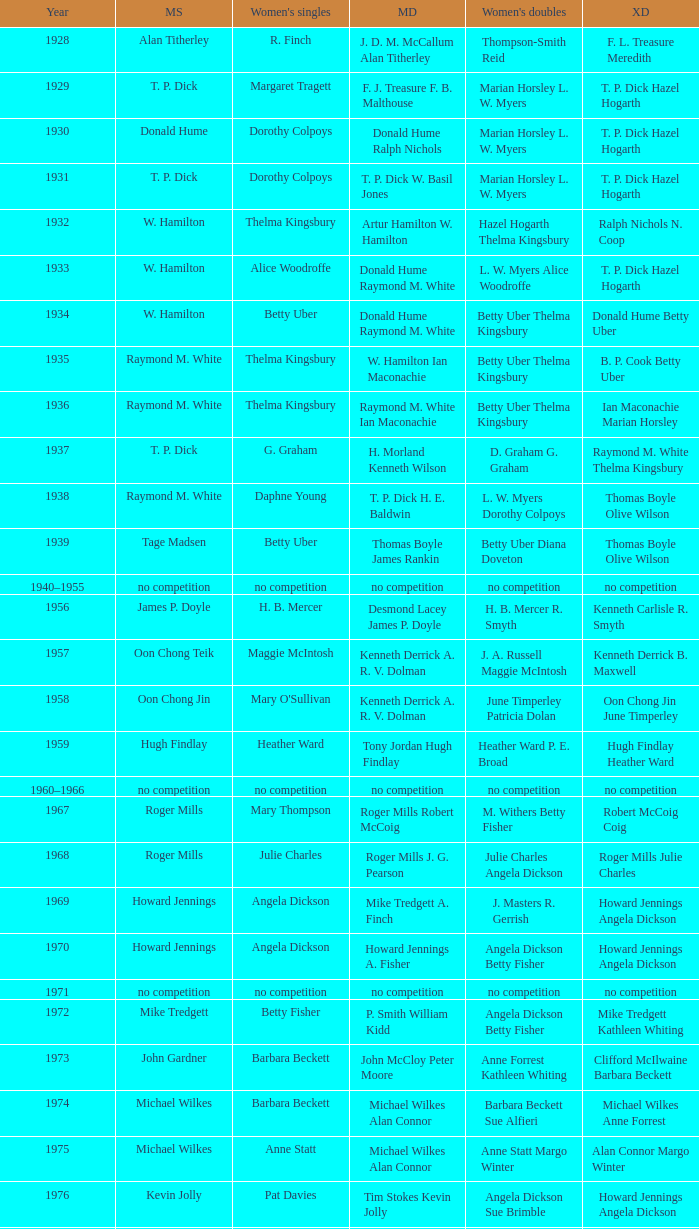Who won the Men's singles in the year that Ian Maconachie Marian Horsley won the Mixed doubles? Raymond M. White. 